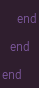<code> <loc_0><loc_0><loc_500><loc_500><_Ruby_>    end
  end
end
</code> 